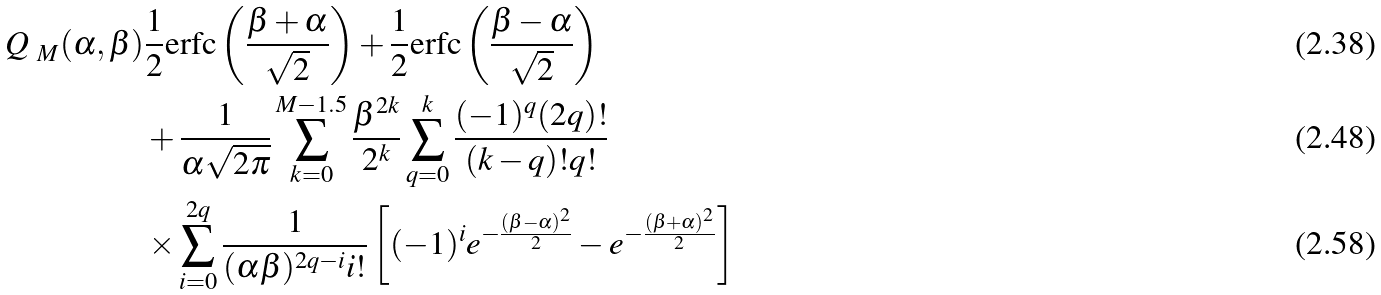<formula> <loc_0><loc_0><loc_500><loc_500>\emph { Q } _ { M } ( \alpha , \beta ) & \frac { 1 } { 2 } \text {erfc} \left ( \frac { \beta + \alpha } { \sqrt { 2 } } \right ) + \frac { 1 } { 2 } \text {erfc} \left ( \frac { \beta - \alpha } { \sqrt { 2 } } \right ) \\ & + \frac { 1 } { \alpha \sqrt { 2 \pi } } \sum _ { k = 0 } ^ { M - 1 . 5 } \frac { \beta ^ { 2 k } } { 2 ^ { k } } \sum _ { q = 0 } ^ { k } \frac { ( - 1 ) ^ { q } ( 2 q ) ! } { ( k - q ) ! q ! } \\ & \times \sum _ { i = 0 } ^ { 2 q } \frac { 1 } { ( \alpha \beta ) ^ { 2 q - i } i ! } \left [ ( - 1 ) ^ { i } e ^ { - \frac { ( \beta - \alpha ) ^ { 2 } } { 2 } } - e ^ { - \frac { ( \beta + \alpha ) ^ { 2 } } { 2 } } \right ]</formula> 